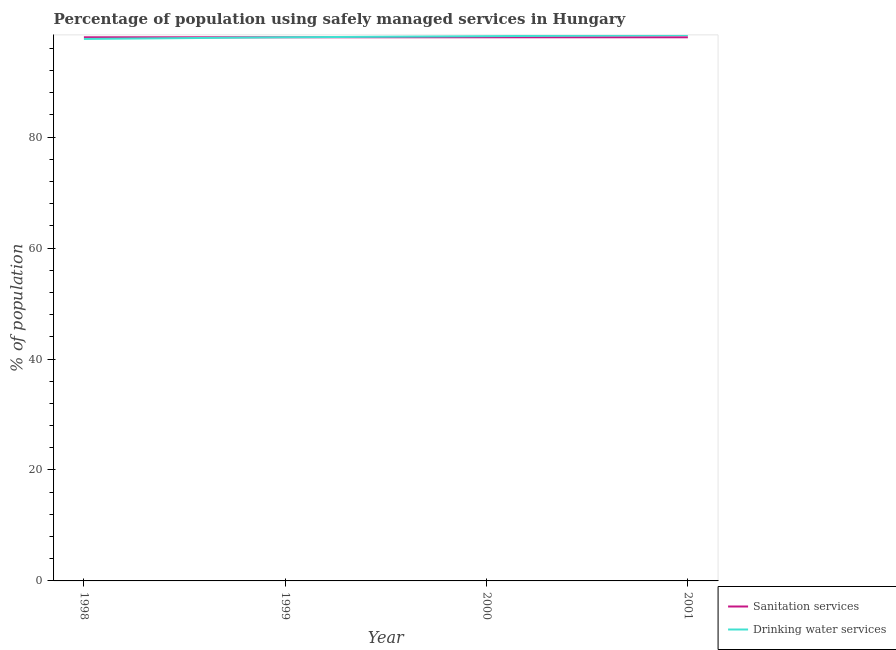Is the number of lines equal to the number of legend labels?
Offer a terse response. Yes. What is the percentage of population who used sanitation services in 1999?
Your response must be concise. 98. Across all years, what is the maximum percentage of population who used sanitation services?
Offer a very short reply. 98. Across all years, what is the minimum percentage of population who used sanitation services?
Your answer should be very brief. 98. In which year was the percentage of population who used sanitation services maximum?
Ensure brevity in your answer.  1998. In which year was the percentage of population who used drinking water services minimum?
Offer a very short reply. 1998. What is the total percentage of population who used sanitation services in the graph?
Make the answer very short. 392. What is the difference between the percentage of population who used sanitation services in 1998 and the percentage of population who used drinking water services in 2000?
Offer a terse response. -0.2. In how many years, is the percentage of population who used sanitation services greater than 88 %?
Keep it short and to the point. 4. What is the ratio of the percentage of population who used drinking water services in 1998 to that in 2000?
Keep it short and to the point. 0.99. Is the percentage of population who used drinking water services in 1999 less than that in 2000?
Your answer should be compact. Yes. Is the difference between the percentage of population who used sanitation services in 2000 and 2001 greater than the difference between the percentage of population who used drinking water services in 2000 and 2001?
Your answer should be very brief. Yes. What is the difference between the highest and the lowest percentage of population who used drinking water services?
Make the answer very short. 0.7. In how many years, is the percentage of population who used sanitation services greater than the average percentage of population who used sanitation services taken over all years?
Provide a short and direct response. 0. Is the percentage of population who used sanitation services strictly greater than the percentage of population who used drinking water services over the years?
Offer a terse response. No. Is the percentage of population who used sanitation services strictly less than the percentage of population who used drinking water services over the years?
Your answer should be compact. No. Does the graph contain any zero values?
Offer a very short reply. No. Where does the legend appear in the graph?
Provide a short and direct response. Bottom right. How many legend labels are there?
Keep it short and to the point. 2. How are the legend labels stacked?
Give a very brief answer. Vertical. What is the title of the graph?
Offer a very short reply. Percentage of population using safely managed services in Hungary. What is the label or title of the X-axis?
Your answer should be very brief. Year. What is the label or title of the Y-axis?
Make the answer very short. % of population. What is the % of population of Drinking water services in 1998?
Offer a terse response. 97.7. What is the % of population in Sanitation services in 1999?
Your response must be concise. 98. What is the % of population of Drinking water services in 1999?
Make the answer very short. 98. What is the % of population in Drinking water services in 2000?
Your answer should be very brief. 98.2. What is the % of population in Sanitation services in 2001?
Your answer should be compact. 98. What is the % of population of Drinking water services in 2001?
Offer a terse response. 98.4. Across all years, what is the maximum % of population of Drinking water services?
Keep it short and to the point. 98.4. Across all years, what is the minimum % of population in Drinking water services?
Make the answer very short. 97.7. What is the total % of population of Sanitation services in the graph?
Keep it short and to the point. 392. What is the total % of population in Drinking water services in the graph?
Provide a short and direct response. 392.3. What is the difference between the % of population of Drinking water services in 1998 and that in 2000?
Offer a very short reply. -0.5. What is the difference between the % of population of Sanitation services in 1998 and that in 2001?
Make the answer very short. 0. What is the difference between the % of population of Drinking water services in 1998 and that in 2001?
Provide a short and direct response. -0.7. What is the difference between the % of population of Sanitation services in 1999 and that in 2000?
Offer a terse response. 0. What is the difference between the % of population in Drinking water services in 1999 and that in 2000?
Ensure brevity in your answer.  -0.2. What is the difference between the % of population in Sanitation services in 2000 and that in 2001?
Give a very brief answer. 0. What is the difference between the % of population in Drinking water services in 2000 and that in 2001?
Provide a succinct answer. -0.2. What is the difference between the % of population of Sanitation services in 1998 and the % of population of Drinking water services in 1999?
Offer a very short reply. 0. What is the difference between the % of population of Sanitation services in 1998 and the % of population of Drinking water services in 2000?
Your answer should be very brief. -0.2. What is the difference between the % of population in Sanitation services in 1998 and the % of population in Drinking water services in 2001?
Ensure brevity in your answer.  -0.4. What is the difference between the % of population of Sanitation services in 2000 and the % of population of Drinking water services in 2001?
Give a very brief answer. -0.4. What is the average % of population in Sanitation services per year?
Offer a terse response. 98. What is the average % of population of Drinking water services per year?
Offer a very short reply. 98.08. In the year 1998, what is the difference between the % of population in Sanitation services and % of population in Drinking water services?
Offer a terse response. 0.3. In the year 1999, what is the difference between the % of population in Sanitation services and % of population in Drinking water services?
Offer a terse response. 0. In the year 2000, what is the difference between the % of population in Sanitation services and % of population in Drinking water services?
Offer a very short reply. -0.2. What is the ratio of the % of population in Sanitation services in 1999 to that in 2000?
Keep it short and to the point. 1. What is the ratio of the % of population in Drinking water services in 2000 to that in 2001?
Provide a short and direct response. 1. What is the difference between the highest and the second highest % of population of Drinking water services?
Make the answer very short. 0.2. What is the difference between the highest and the lowest % of population of Sanitation services?
Your response must be concise. 0. What is the difference between the highest and the lowest % of population in Drinking water services?
Offer a terse response. 0.7. 